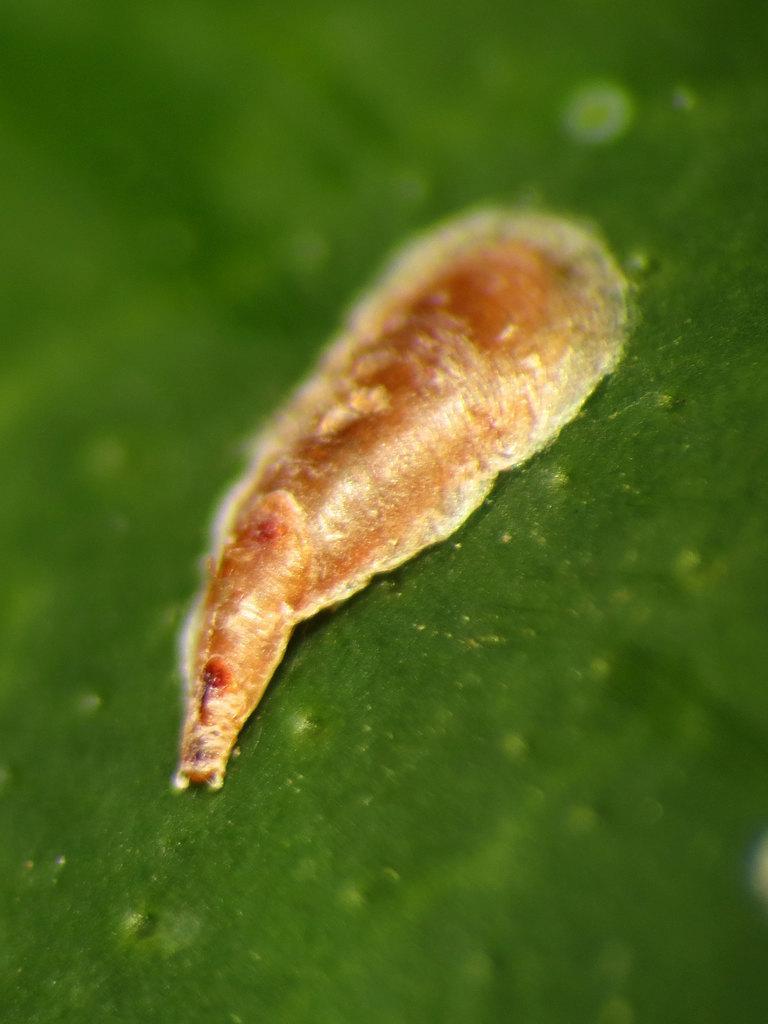How would you summarize this image in a sentence or two? In this picture we can see warm on the green surface. In the background of the image it is blue and green. 